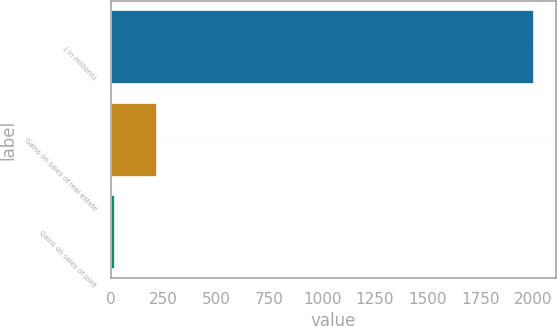Convert chart. <chart><loc_0><loc_0><loc_500><loc_500><bar_chart><fcel>( in millions)<fcel>Gains on sales of real estate<fcel>Gains on sales of joint<nl><fcel>2004<fcel>217.5<fcel>19<nl></chart> 